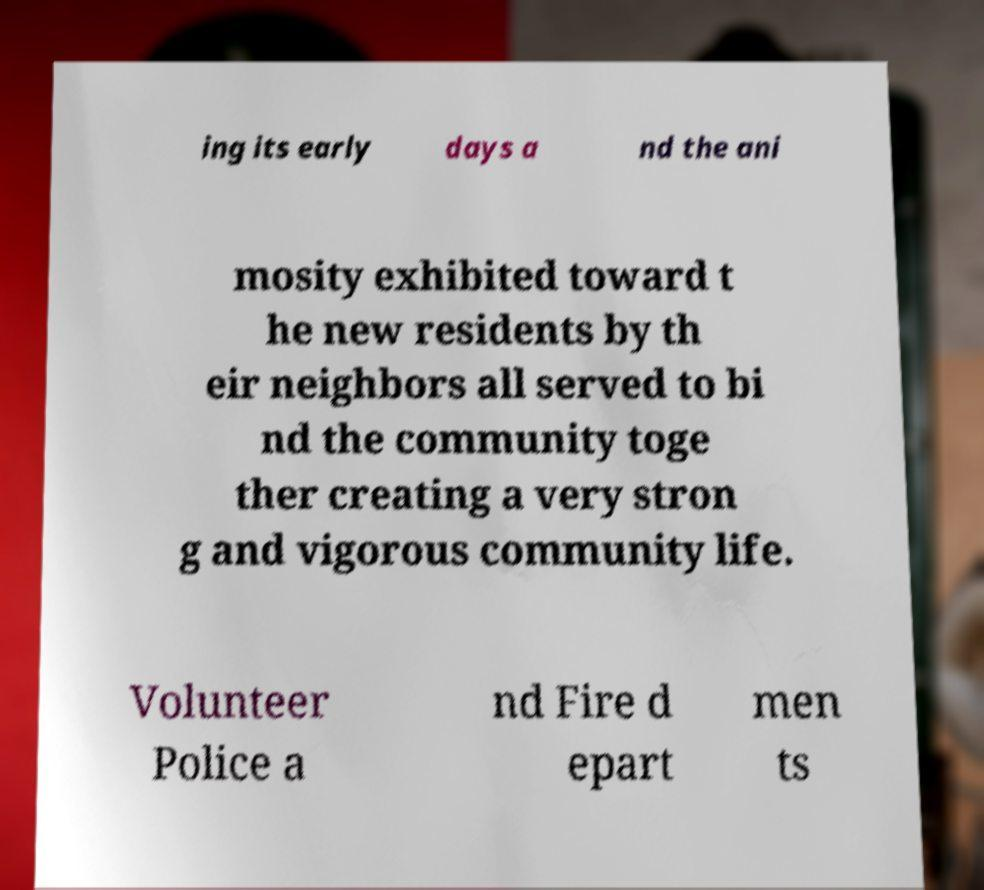Please read and relay the text visible in this image. What does it say? ing its early days a nd the ani mosity exhibited toward t he new residents by th eir neighbors all served to bi nd the community toge ther creating a very stron g and vigorous community life. Volunteer Police a nd Fire d epart men ts 